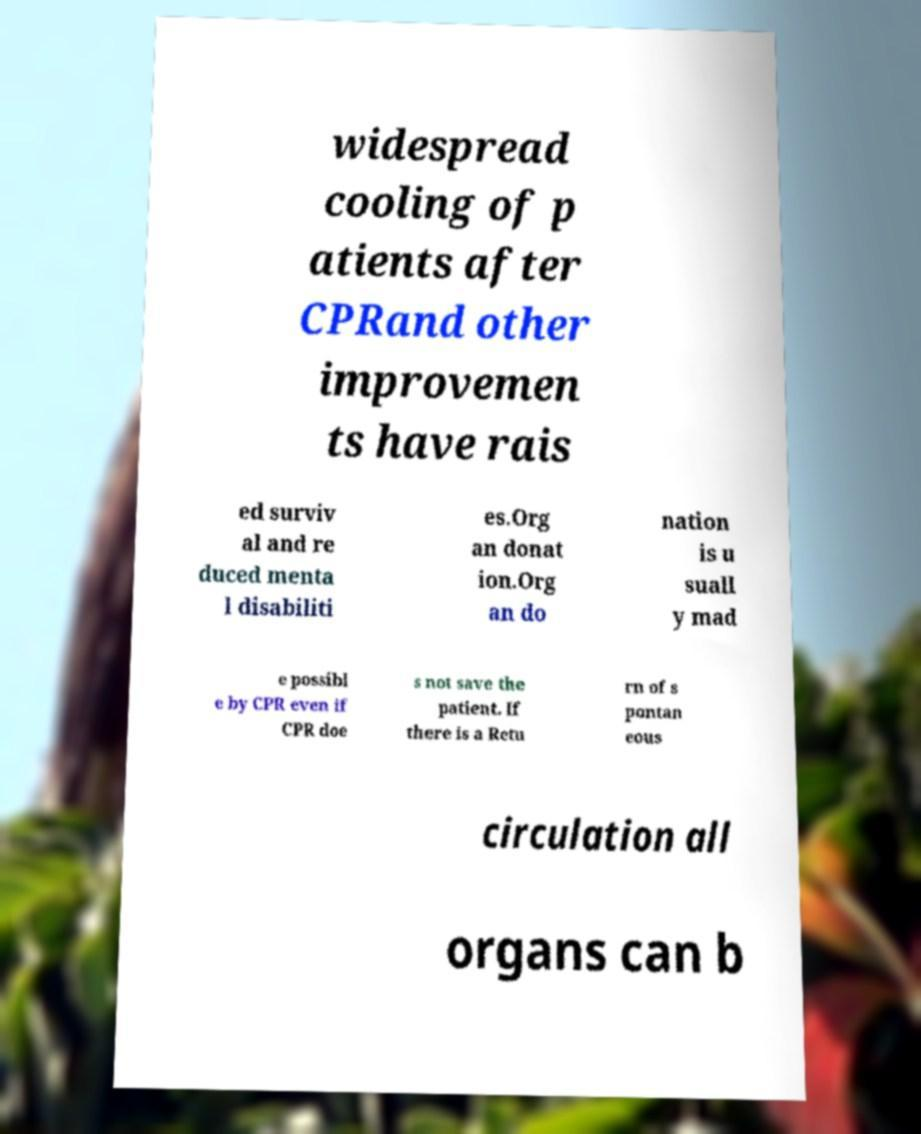For documentation purposes, I need the text within this image transcribed. Could you provide that? widespread cooling of p atients after CPRand other improvemen ts have rais ed surviv al and re duced menta l disabiliti es.Org an donat ion.Org an do nation is u suall y mad e possibl e by CPR even if CPR doe s not save the patient. If there is a Retu rn of s pontan eous circulation all organs can b 